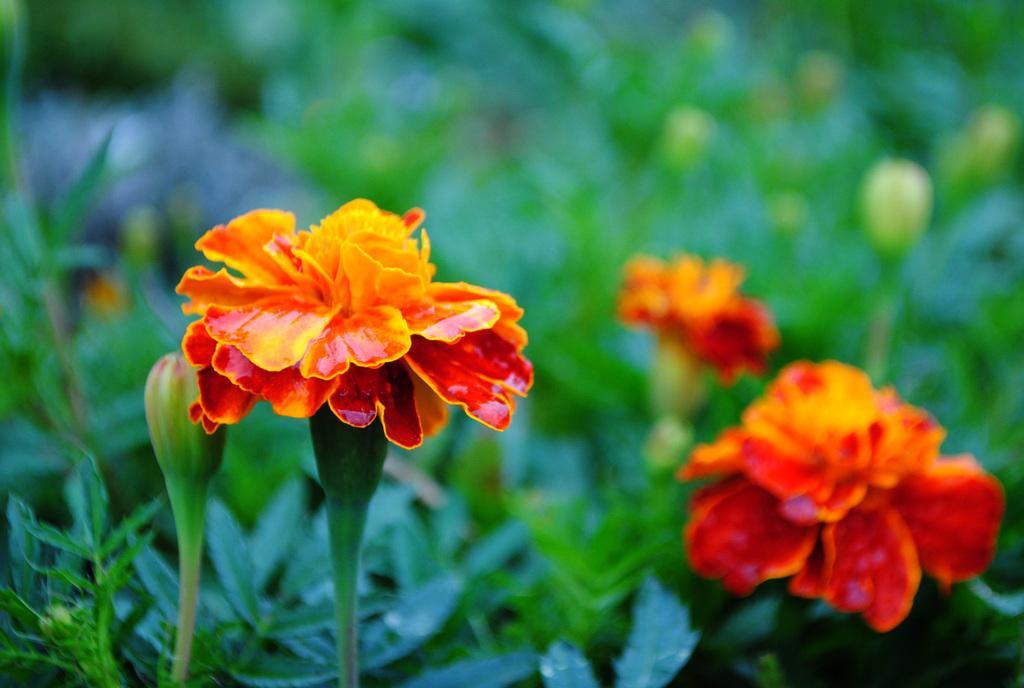How would you summarize this image in a sentence or two? In this picture we can see orange color flowers on the plant. Beside that we can see some buds. At the bottom we can see leaves. 